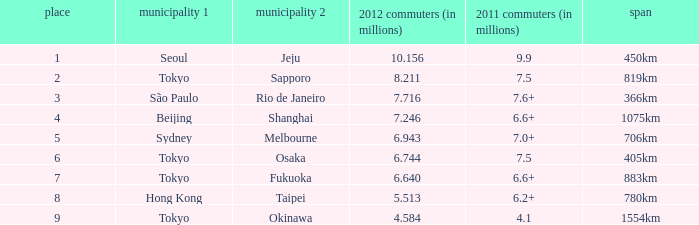How many passengers (in millions) in 2011 flew through along the route that had 6.640 million passengers in 2012? 6.6+. 